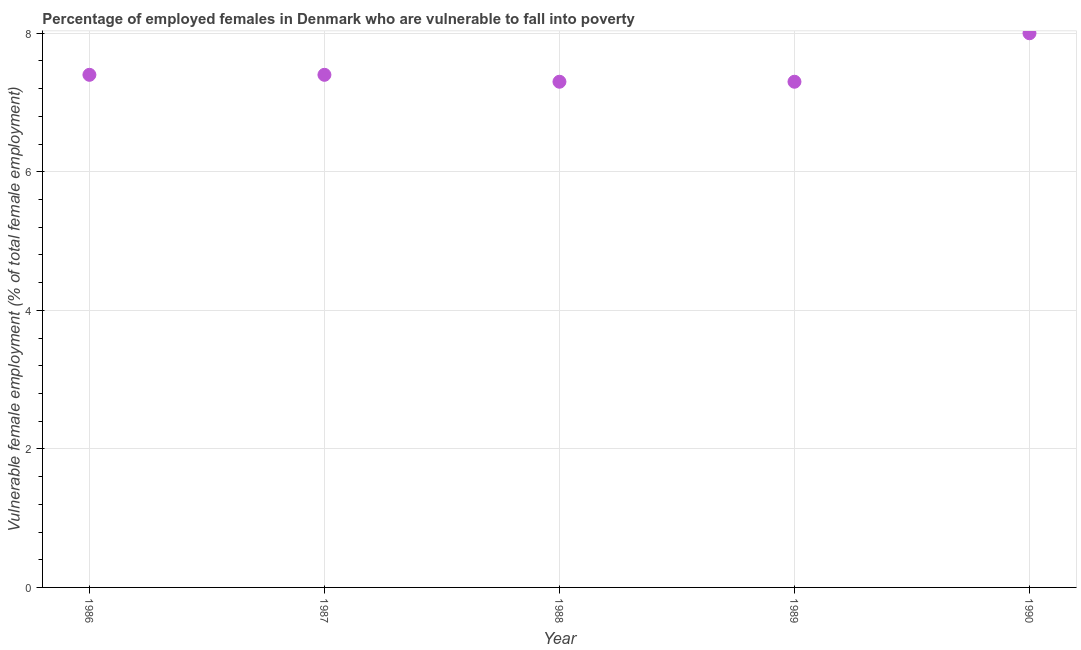What is the percentage of employed females who are vulnerable to fall into poverty in 1986?
Provide a short and direct response. 7.4. Across all years, what is the minimum percentage of employed females who are vulnerable to fall into poverty?
Offer a very short reply. 7.3. In which year was the percentage of employed females who are vulnerable to fall into poverty minimum?
Provide a succinct answer. 1988. What is the sum of the percentage of employed females who are vulnerable to fall into poverty?
Offer a terse response. 37.4. What is the difference between the percentage of employed females who are vulnerable to fall into poverty in 1988 and 1989?
Provide a short and direct response. 0. What is the average percentage of employed females who are vulnerable to fall into poverty per year?
Provide a short and direct response. 7.48. What is the median percentage of employed females who are vulnerable to fall into poverty?
Offer a terse response. 7.4. What is the ratio of the percentage of employed females who are vulnerable to fall into poverty in 1986 to that in 1988?
Offer a terse response. 1.01. Is the difference between the percentage of employed females who are vulnerable to fall into poverty in 1989 and 1990 greater than the difference between any two years?
Ensure brevity in your answer.  Yes. What is the difference between the highest and the second highest percentage of employed females who are vulnerable to fall into poverty?
Ensure brevity in your answer.  0.6. What is the difference between the highest and the lowest percentage of employed females who are vulnerable to fall into poverty?
Provide a short and direct response. 0.7. In how many years, is the percentage of employed females who are vulnerable to fall into poverty greater than the average percentage of employed females who are vulnerable to fall into poverty taken over all years?
Give a very brief answer. 1. Does the percentage of employed females who are vulnerable to fall into poverty monotonically increase over the years?
Provide a short and direct response. No. How many dotlines are there?
Ensure brevity in your answer.  1. How many years are there in the graph?
Your response must be concise. 5. Are the values on the major ticks of Y-axis written in scientific E-notation?
Provide a succinct answer. No. Does the graph contain grids?
Offer a very short reply. Yes. What is the title of the graph?
Your answer should be very brief. Percentage of employed females in Denmark who are vulnerable to fall into poverty. What is the label or title of the X-axis?
Make the answer very short. Year. What is the label or title of the Y-axis?
Keep it short and to the point. Vulnerable female employment (% of total female employment). What is the Vulnerable female employment (% of total female employment) in 1986?
Your response must be concise. 7.4. What is the Vulnerable female employment (% of total female employment) in 1987?
Keep it short and to the point. 7.4. What is the Vulnerable female employment (% of total female employment) in 1988?
Provide a succinct answer. 7.3. What is the Vulnerable female employment (% of total female employment) in 1989?
Make the answer very short. 7.3. What is the difference between the Vulnerable female employment (% of total female employment) in 1986 and 1987?
Your response must be concise. 0. What is the difference between the Vulnerable female employment (% of total female employment) in 1986 and 1990?
Offer a terse response. -0.6. What is the difference between the Vulnerable female employment (% of total female employment) in 1987 and 1990?
Provide a short and direct response. -0.6. What is the difference between the Vulnerable female employment (% of total female employment) in 1988 and 1989?
Keep it short and to the point. 0. What is the difference between the Vulnerable female employment (% of total female employment) in 1989 and 1990?
Offer a terse response. -0.7. What is the ratio of the Vulnerable female employment (% of total female employment) in 1986 to that in 1988?
Keep it short and to the point. 1.01. What is the ratio of the Vulnerable female employment (% of total female employment) in 1986 to that in 1989?
Your answer should be very brief. 1.01. What is the ratio of the Vulnerable female employment (% of total female employment) in 1986 to that in 1990?
Offer a terse response. 0.93. What is the ratio of the Vulnerable female employment (% of total female employment) in 1987 to that in 1989?
Keep it short and to the point. 1.01. What is the ratio of the Vulnerable female employment (% of total female employment) in 1987 to that in 1990?
Provide a short and direct response. 0.93. 